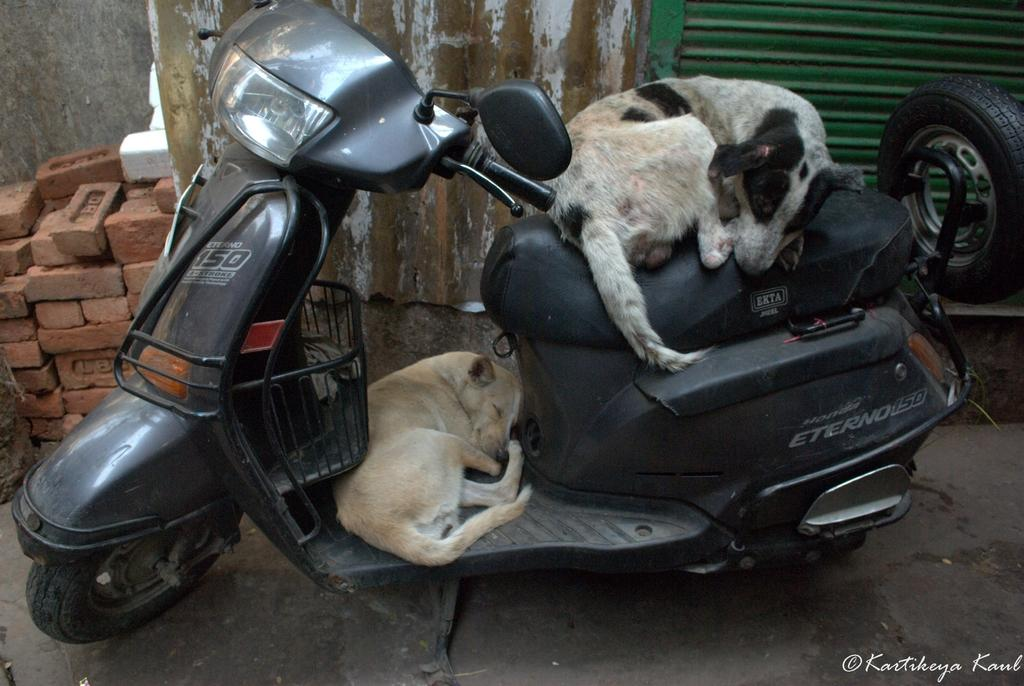What is the main object in the image? There is a scooter in the image. What is on the scooter? There are two dogs on the scooter. What can be seen in the background of the image? There is a brick and a wall in the background of the image. What is the condition of the scooter? There is a shatter in the image, which suggests that the scooter might be damaged. How does the dust affect the dogs' surprise in the image? There is no dust or surprise present in the image; it features a scooter with two dogs and a shattered background. What type of hook can be seen attached to the scooter in the image? There is no hook present on the scooter in the image. 